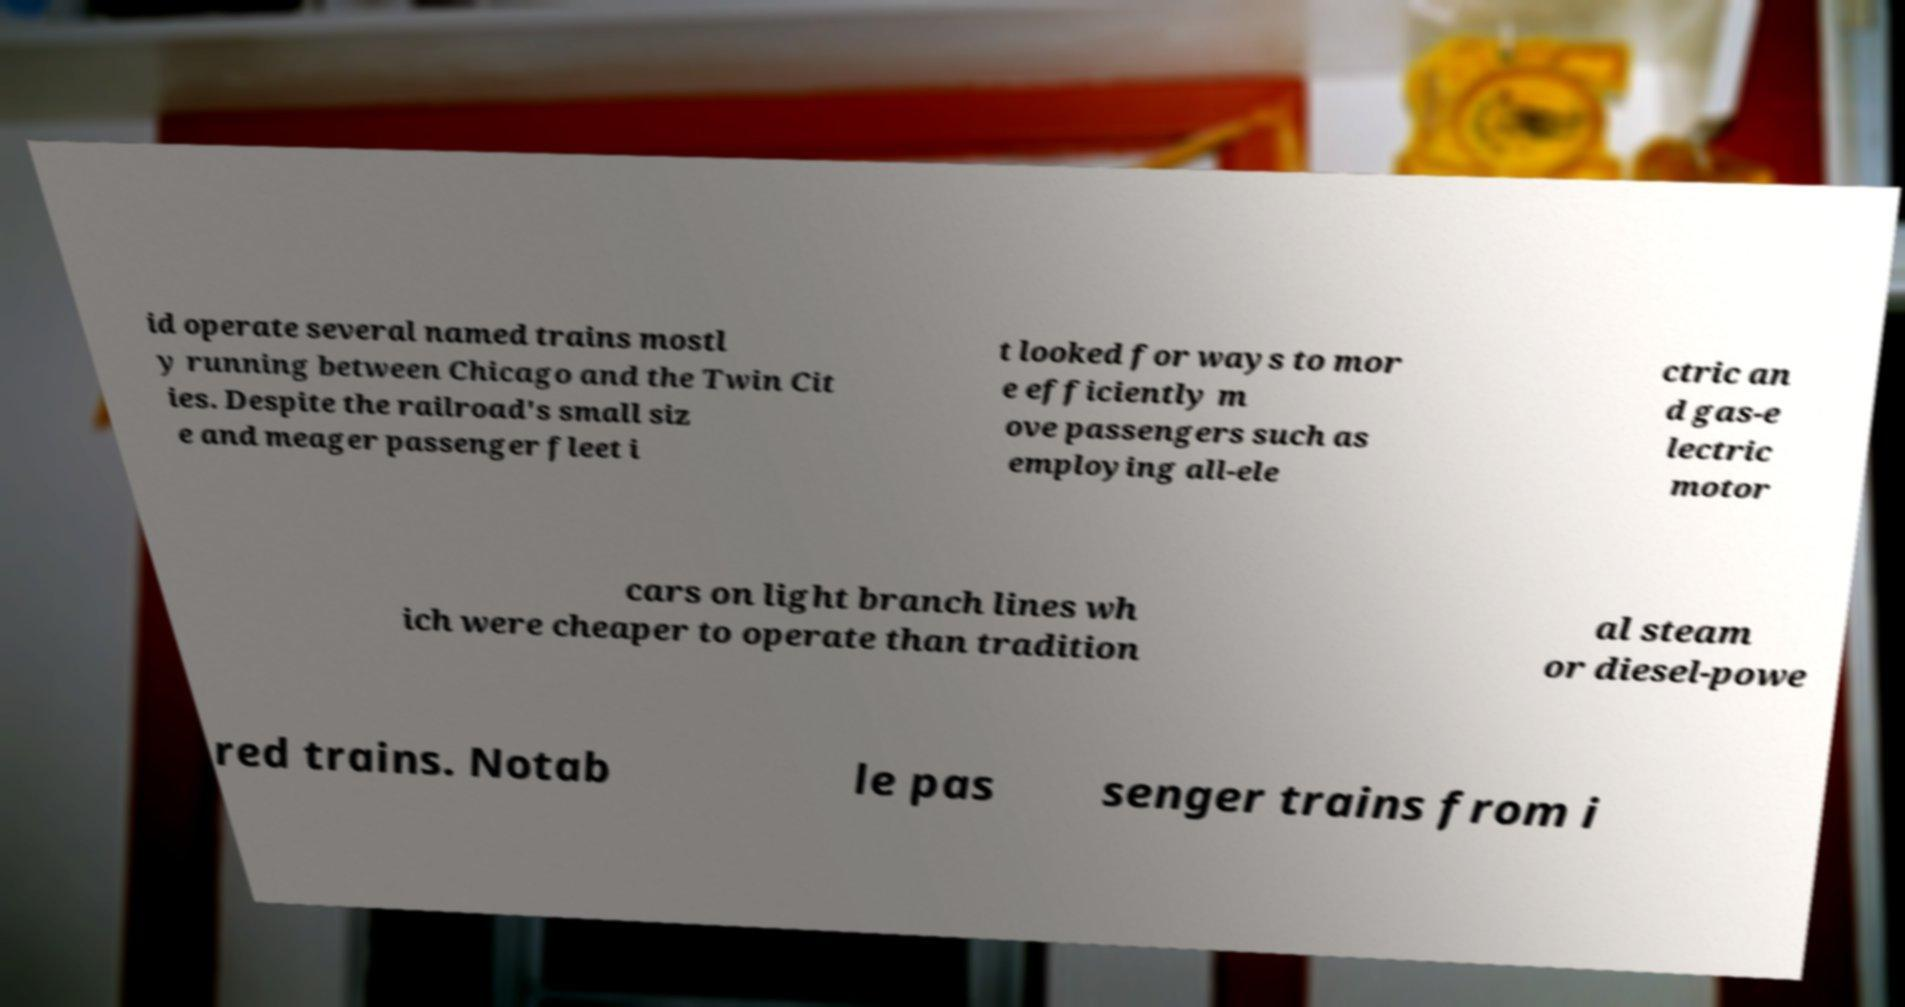Could you extract and type out the text from this image? id operate several named trains mostl y running between Chicago and the Twin Cit ies. Despite the railroad's small siz e and meager passenger fleet i t looked for ways to mor e efficiently m ove passengers such as employing all-ele ctric an d gas-e lectric motor cars on light branch lines wh ich were cheaper to operate than tradition al steam or diesel-powe red trains. Notab le pas senger trains from i 